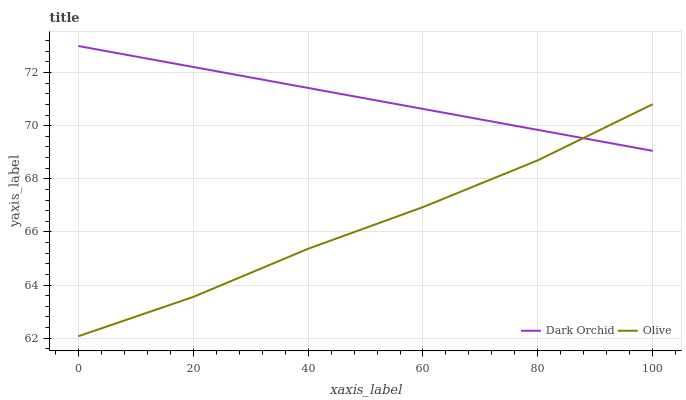Does Olive have the minimum area under the curve?
Answer yes or no. Yes. Does Dark Orchid have the maximum area under the curve?
Answer yes or no. Yes. Does Dark Orchid have the minimum area under the curve?
Answer yes or no. No. Is Dark Orchid the smoothest?
Answer yes or no. Yes. Is Olive the roughest?
Answer yes or no. Yes. Is Dark Orchid the roughest?
Answer yes or no. No. Does Dark Orchid have the lowest value?
Answer yes or no. No. Does Dark Orchid have the highest value?
Answer yes or no. Yes. Does Dark Orchid intersect Olive?
Answer yes or no. Yes. Is Dark Orchid less than Olive?
Answer yes or no. No. Is Dark Orchid greater than Olive?
Answer yes or no. No. 